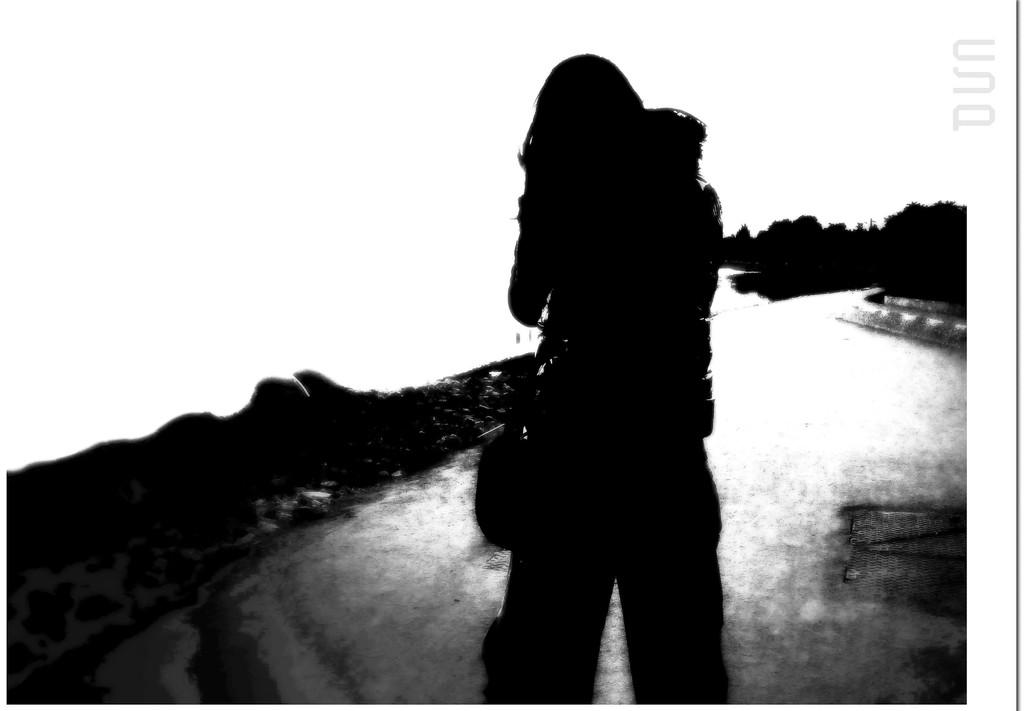What is the main subject of the image? There is a person in the image. What can be seen in the background of the image? There are trees in the background of the image. What type of trouble is the person experiencing in the image? There is no indication of any trouble in the image; it only shows a person and trees in the background. What kind of wrench is being used by the person in the image? There is no wrench present in the image. What is the slope of the terrain in the image? There is no information about the terrain or any slope in the image. 